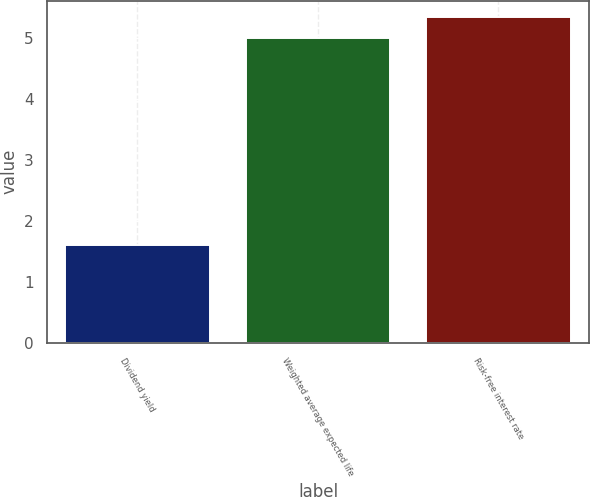Convert chart to OTSL. <chart><loc_0><loc_0><loc_500><loc_500><bar_chart><fcel>Dividend yield<fcel>Weighted average expected life<fcel>Risk-free interest rate<nl><fcel>1.6<fcel>5<fcel>5.34<nl></chart> 